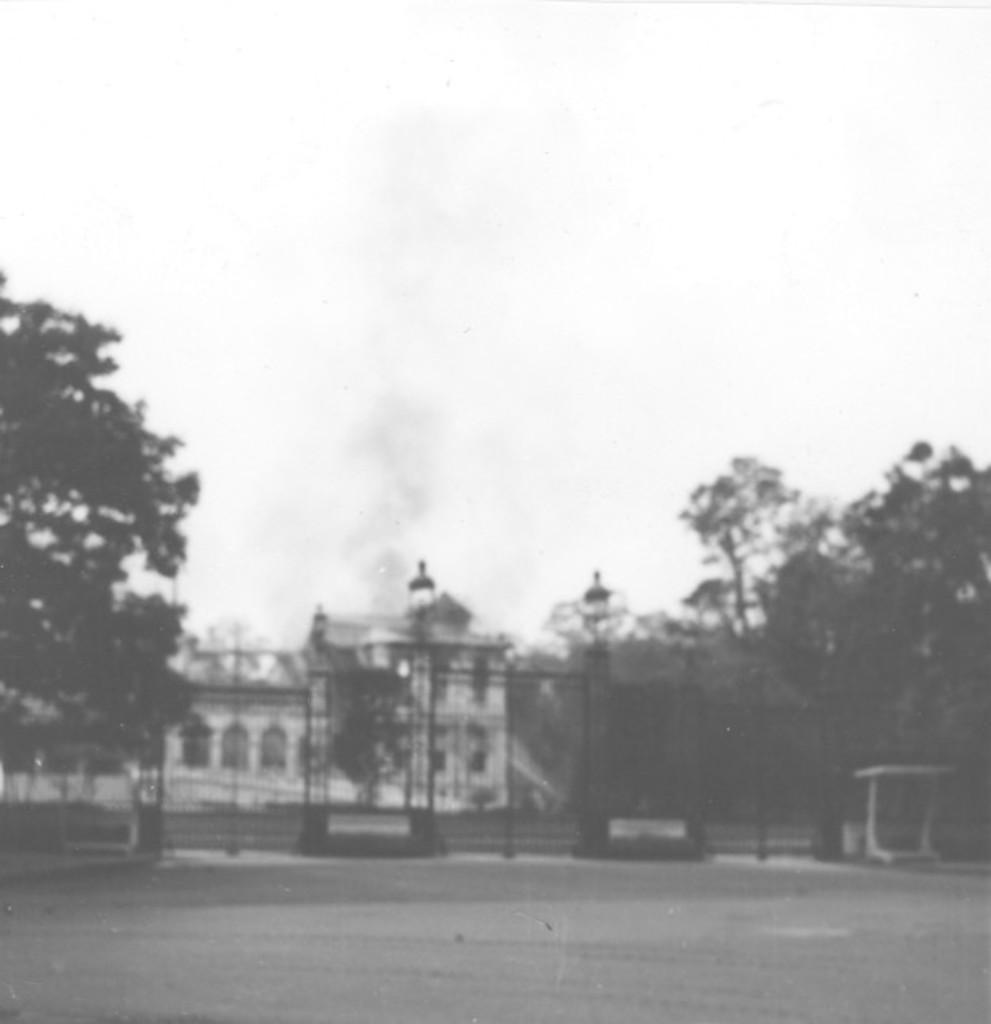What is the color scheme of the image? The image is black and white. What can be seen in the image besides the color scheme? There is a black gate, a building, trees, smoke, and the sky visible in the image. What type of linen is being used to cover the society in the image? There is no linen or society present in the image; it features a black gate, a building, trees, smoke, and the sky. 